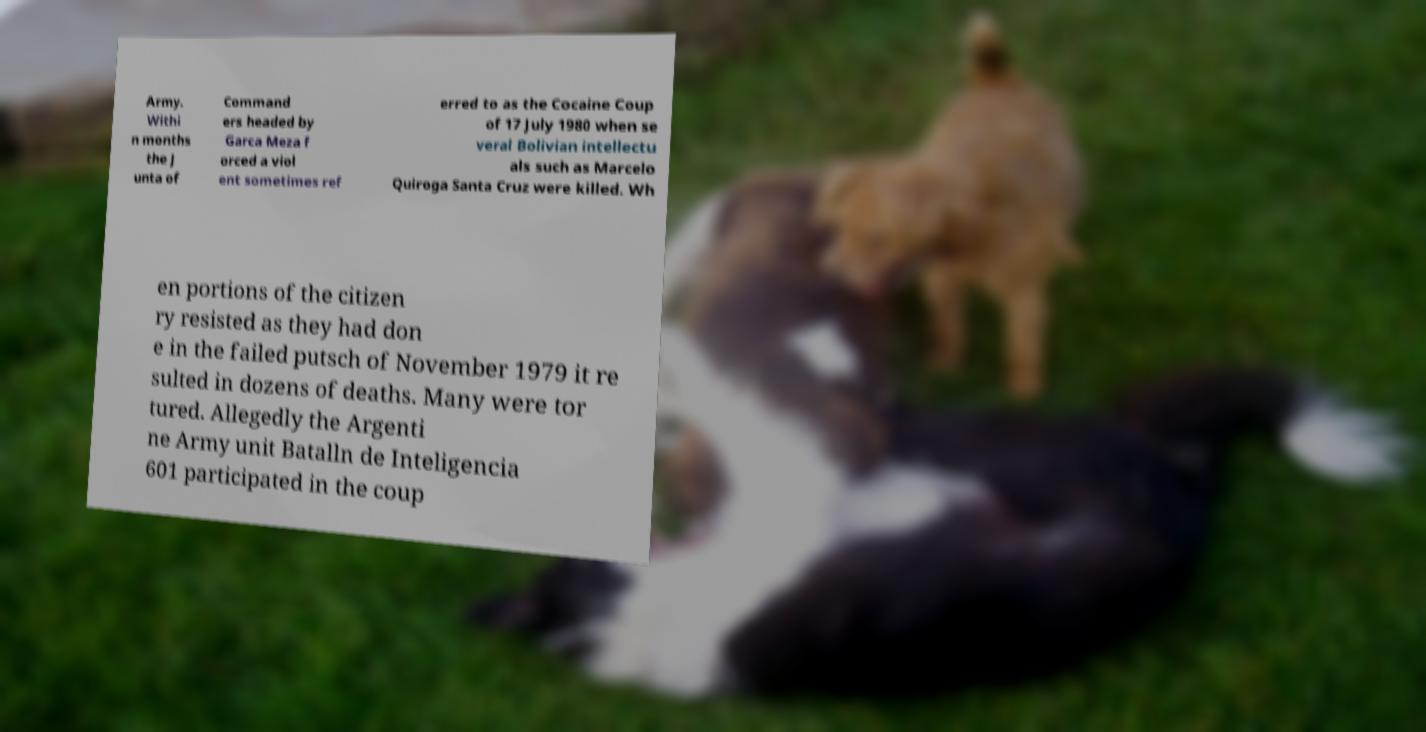Could you assist in decoding the text presented in this image and type it out clearly? Army. Withi n months the J unta of Command ers headed by Garca Meza f orced a viol ent sometimes ref erred to as the Cocaine Coup of 17 July 1980 when se veral Bolivian intellectu als such as Marcelo Quiroga Santa Cruz were killed. Wh en portions of the citizen ry resisted as they had don e in the failed putsch of November 1979 it re sulted in dozens of deaths. Many were tor tured. Allegedly the Argenti ne Army unit Batalln de Inteligencia 601 participated in the coup 